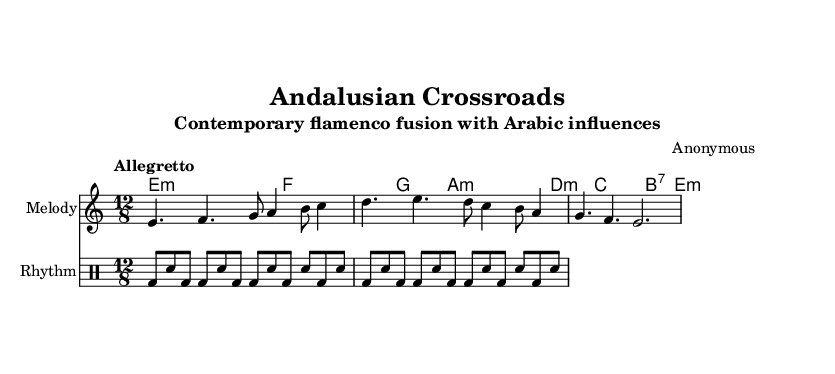What is the key signature of this music? The key signature indicated in the sheet music is E Phrygian, which has a total of one flat (D#).
Answer: E Phrygian What is the time signature of this piece? The time signature displayed in the sheet music is 12/8, which indicates a compound time feel with twelve beats in a measure, grouped into four sets of three.
Answer: 12/8 What is the tempo marking for the piece? The tempo marking states "Allegretto," which corresponds to a moderately fast tempo, typically around 98-109 beats per minute.
Answer: Allegretto How many measures are in the melody section? Counting the measures indicated in the melody part, there are a total of three measures that are distinct in the provided music notation.
Answer: 3 What type of harmonies are used in this piece? The sheet music shows that the harmonies primarily include minor chords, specifically indicating E minor and A minor among others, which are characteristic of both flamenco and Arabic music.
Answer: Minor chords What rhythmic pattern is being utilized in the drum part? The rhythmic pattern in the drum section consists of a repetitive structure characterized by bass drum and snare combinations, typical in flamenco-influenced music, and emphasizing syncopation and groove.
Answer: Bass and snare pattern 